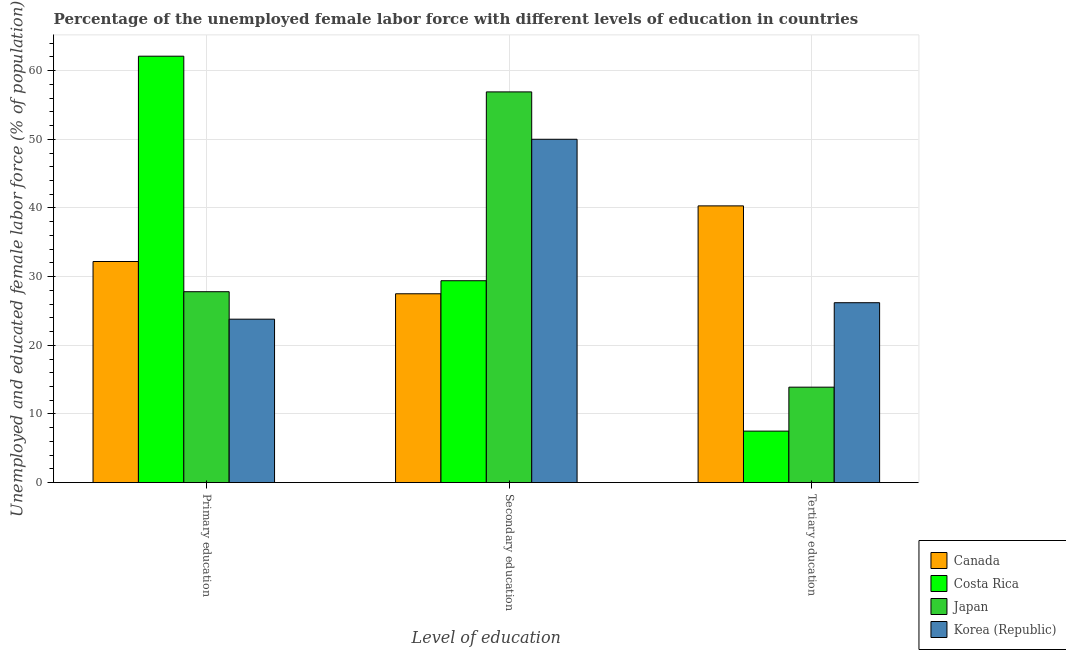How many groups of bars are there?
Keep it short and to the point. 3. How many bars are there on the 2nd tick from the left?
Give a very brief answer. 4. What is the label of the 1st group of bars from the left?
Provide a short and direct response. Primary education. What is the percentage of female labor force who received tertiary education in Canada?
Ensure brevity in your answer.  40.3. Across all countries, what is the maximum percentage of female labor force who received primary education?
Provide a short and direct response. 62.1. In which country was the percentage of female labor force who received tertiary education maximum?
Offer a terse response. Canada. What is the total percentage of female labor force who received secondary education in the graph?
Your response must be concise. 163.8. What is the difference between the percentage of female labor force who received tertiary education in Korea (Republic) and that in Costa Rica?
Give a very brief answer. 18.7. What is the difference between the percentage of female labor force who received tertiary education in Korea (Republic) and the percentage of female labor force who received secondary education in Japan?
Provide a short and direct response. -30.7. What is the average percentage of female labor force who received primary education per country?
Provide a short and direct response. 36.47. What is the difference between the percentage of female labor force who received primary education and percentage of female labor force who received tertiary education in Japan?
Keep it short and to the point. 13.9. In how many countries, is the percentage of female labor force who received tertiary education greater than 58 %?
Provide a succinct answer. 0. What is the ratio of the percentage of female labor force who received primary education in Canada to that in Costa Rica?
Your answer should be compact. 0.52. Is the percentage of female labor force who received primary education in Korea (Republic) less than that in Costa Rica?
Keep it short and to the point. Yes. What is the difference between the highest and the second highest percentage of female labor force who received secondary education?
Your response must be concise. 6.9. What is the difference between the highest and the lowest percentage of female labor force who received tertiary education?
Provide a short and direct response. 32.8. In how many countries, is the percentage of female labor force who received secondary education greater than the average percentage of female labor force who received secondary education taken over all countries?
Give a very brief answer. 2. How many bars are there?
Make the answer very short. 12. How many countries are there in the graph?
Make the answer very short. 4. What is the difference between two consecutive major ticks on the Y-axis?
Provide a short and direct response. 10. Does the graph contain any zero values?
Provide a succinct answer. No. How many legend labels are there?
Keep it short and to the point. 4. What is the title of the graph?
Offer a very short reply. Percentage of the unemployed female labor force with different levels of education in countries. Does "Middle East & North Africa (developing only)" appear as one of the legend labels in the graph?
Offer a terse response. No. What is the label or title of the X-axis?
Ensure brevity in your answer.  Level of education. What is the label or title of the Y-axis?
Your response must be concise. Unemployed and educated female labor force (% of population). What is the Unemployed and educated female labor force (% of population) of Canada in Primary education?
Offer a terse response. 32.2. What is the Unemployed and educated female labor force (% of population) in Costa Rica in Primary education?
Your response must be concise. 62.1. What is the Unemployed and educated female labor force (% of population) of Japan in Primary education?
Provide a short and direct response. 27.8. What is the Unemployed and educated female labor force (% of population) of Korea (Republic) in Primary education?
Provide a succinct answer. 23.8. What is the Unemployed and educated female labor force (% of population) of Costa Rica in Secondary education?
Your answer should be very brief. 29.4. What is the Unemployed and educated female labor force (% of population) of Japan in Secondary education?
Offer a terse response. 56.9. What is the Unemployed and educated female labor force (% of population) in Canada in Tertiary education?
Provide a short and direct response. 40.3. What is the Unemployed and educated female labor force (% of population) of Japan in Tertiary education?
Your answer should be compact. 13.9. What is the Unemployed and educated female labor force (% of population) of Korea (Republic) in Tertiary education?
Your response must be concise. 26.2. Across all Level of education, what is the maximum Unemployed and educated female labor force (% of population) in Canada?
Provide a short and direct response. 40.3. Across all Level of education, what is the maximum Unemployed and educated female labor force (% of population) of Costa Rica?
Offer a very short reply. 62.1. Across all Level of education, what is the maximum Unemployed and educated female labor force (% of population) of Japan?
Your response must be concise. 56.9. Across all Level of education, what is the maximum Unemployed and educated female labor force (% of population) in Korea (Republic)?
Your answer should be compact. 50. Across all Level of education, what is the minimum Unemployed and educated female labor force (% of population) of Canada?
Your answer should be compact. 27.5. Across all Level of education, what is the minimum Unemployed and educated female labor force (% of population) in Costa Rica?
Your answer should be very brief. 7.5. Across all Level of education, what is the minimum Unemployed and educated female labor force (% of population) of Japan?
Your answer should be compact. 13.9. Across all Level of education, what is the minimum Unemployed and educated female labor force (% of population) of Korea (Republic)?
Your answer should be very brief. 23.8. What is the total Unemployed and educated female labor force (% of population) of Canada in the graph?
Ensure brevity in your answer.  100. What is the total Unemployed and educated female labor force (% of population) of Costa Rica in the graph?
Give a very brief answer. 99. What is the total Unemployed and educated female labor force (% of population) in Japan in the graph?
Offer a very short reply. 98.6. What is the total Unemployed and educated female labor force (% of population) in Korea (Republic) in the graph?
Your answer should be compact. 100. What is the difference between the Unemployed and educated female labor force (% of population) in Costa Rica in Primary education and that in Secondary education?
Your answer should be compact. 32.7. What is the difference between the Unemployed and educated female labor force (% of population) of Japan in Primary education and that in Secondary education?
Give a very brief answer. -29.1. What is the difference between the Unemployed and educated female labor force (% of population) in Korea (Republic) in Primary education and that in Secondary education?
Make the answer very short. -26.2. What is the difference between the Unemployed and educated female labor force (% of population) of Costa Rica in Primary education and that in Tertiary education?
Offer a terse response. 54.6. What is the difference between the Unemployed and educated female labor force (% of population) of Japan in Primary education and that in Tertiary education?
Offer a very short reply. 13.9. What is the difference between the Unemployed and educated female labor force (% of population) in Korea (Republic) in Primary education and that in Tertiary education?
Keep it short and to the point. -2.4. What is the difference between the Unemployed and educated female labor force (% of population) of Canada in Secondary education and that in Tertiary education?
Your answer should be very brief. -12.8. What is the difference between the Unemployed and educated female labor force (% of population) of Costa Rica in Secondary education and that in Tertiary education?
Offer a very short reply. 21.9. What is the difference between the Unemployed and educated female labor force (% of population) of Japan in Secondary education and that in Tertiary education?
Keep it short and to the point. 43. What is the difference between the Unemployed and educated female labor force (% of population) of Korea (Republic) in Secondary education and that in Tertiary education?
Make the answer very short. 23.8. What is the difference between the Unemployed and educated female labor force (% of population) in Canada in Primary education and the Unemployed and educated female labor force (% of population) in Costa Rica in Secondary education?
Make the answer very short. 2.8. What is the difference between the Unemployed and educated female labor force (% of population) in Canada in Primary education and the Unemployed and educated female labor force (% of population) in Japan in Secondary education?
Offer a terse response. -24.7. What is the difference between the Unemployed and educated female labor force (% of population) of Canada in Primary education and the Unemployed and educated female labor force (% of population) of Korea (Republic) in Secondary education?
Your response must be concise. -17.8. What is the difference between the Unemployed and educated female labor force (% of population) of Costa Rica in Primary education and the Unemployed and educated female labor force (% of population) of Japan in Secondary education?
Ensure brevity in your answer.  5.2. What is the difference between the Unemployed and educated female labor force (% of population) of Japan in Primary education and the Unemployed and educated female labor force (% of population) of Korea (Republic) in Secondary education?
Your response must be concise. -22.2. What is the difference between the Unemployed and educated female labor force (% of population) in Canada in Primary education and the Unemployed and educated female labor force (% of population) in Costa Rica in Tertiary education?
Ensure brevity in your answer.  24.7. What is the difference between the Unemployed and educated female labor force (% of population) of Canada in Primary education and the Unemployed and educated female labor force (% of population) of Japan in Tertiary education?
Provide a succinct answer. 18.3. What is the difference between the Unemployed and educated female labor force (% of population) of Costa Rica in Primary education and the Unemployed and educated female labor force (% of population) of Japan in Tertiary education?
Make the answer very short. 48.2. What is the difference between the Unemployed and educated female labor force (% of population) of Costa Rica in Primary education and the Unemployed and educated female labor force (% of population) of Korea (Republic) in Tertiary education?
Your response must be concise. 35.9. What is the difference between the Unemployed and educated female labor force (% of population) of Canada in Secondary education and the Unemployed and educated female labor force (% of population) of Costa Rica in Tertiary education?
Provide a succinct answer. 20. What is the difference between the Unemployed and educated female labor force (% of population) in Canada in Secondary education and the Unemployed and educated female labor force (% of population) in Korea (Republic) in Tertiary education?
Keep it short and to the point. 1.3. What is the difference between the Unemployed and educated female labor force (% of population) of Japan in Secondary education and the Unemployed and educated female labor force (% of population) of Korea (Republic) in Tertiary education?
Your answer should be compact. 30.7. What is the average Unemployed and educated female labor force (% of population) of Canada per Level of education?
Ensure brevity in your answer.  33.33. What is the average Unemployed and educated female labor force (% of population) of Japan per Level of education?
Provide a short and direct response. 32.87. What is the average Unemployed and educated female labor force (% of population) in Korea (Republic) per Level of education?
Keep it short and to the point. 33.33. What is the difference between the Unemployed and educated female labor force (% of population) in Canada and Unemployed and educated female labor force (% of population) in Costa Rica in Primary education?
Provide a short and direct response. -29.9. What is the difference between the Unemployed and educated female labor force (% of population) in Canada and Unemployed and educated female labor force (% of population) in Japan in Primary education?
Your answer should be compact. 4.4. What is the difference between the Unemployed and educated female labor force (% of population) in Costa Rica and Unemployed and educated female labor force (% of population) in Japan in Primary education?
Provide a succinct answer. 34.3. What is the difference between the Unemployed and educated female labor force (% of population) of Costa Rica and Unemployed and educated female labor force (% of population) of Korea (Republic) in Primary education?
Offer a very short reply. 38.3. What is the difference between the Unemployed and educated female labor force (% of population) of Japan and Unemployed and educated female labor force (% of population) of Korea (Republic) in Primary education?
Make the answer very short. 4. What is the difference between the Unemployed and educated female labor force (% of population) in Canada and Unemployed and educated female labor force (% of population) in Costa Rica in Secondary education?
Your answer should be compact. -1.9. What is the difference between the Unemployed and educated female labor force (% of population) of Canada and Unemployed and educated female labor force (% of population) of Japan in Secondary education?
Ensure brevity in your answer.  -29.4. What is the difference between the Unemployed and educated female labor force (% of population) of Canada and Unemployed and educated female labor force (% of population) of Korea (Republic) in Secondary education?
Your response must be concise. -22.5. What is the difference between the Unemployed and educated female labor force (% of population) in Costa Rica and Unemployed and educated female labor force (% of population) in Japan in Secondary education?
Provide a short and direct response. -27.5. What is the difference between the Unemployed and educated female labor force (% of population) in Costa Rica and Unemployed and educated female labor force (% of population) in Korea (Republic) in Secondary education?
Offer a terse response. -20.6. What is the difference between the Unemployed and educated female labor force (% of population) of Japan and Unemployed and educated female labor force (% of population) of Korea (Republic) in Secondary education?
Ensure brevity in your answer.  6.9. What is the difference between the Unemployed and educated female labor force (% of population) in Canada and Unemployed and educated female labor force (% of population) in Costa Rica in Tertiary education?
Your response must be concise. 32.8. What is the difference between the Unemployed and educated female labor force (% of population) in Canada and Unemployed and educated female labor force (% of population) in Japan in Tertiary education?
Provide a succinct answer. 26.4. What is the difference between the Unemployed and educated female labor force (% of population) of Canada and Unemployed and educated female labor force (% of population) of Korea (Republic) in Tertiary education?
Keep it short and to the point. 14.1. What is the difference between the Unemployed and educated female labor force (% of population) in Costa Rica and Unemployed and educated female labor force (% of population) in Japan in Tertiary education?
Offer a terse response. -6.4. What is the difference between the Unemployed and educated female labor force (% of population) of Costa Rica and Unemployed and educated female labor force (% of population) of Korea (Republic) in Tertiary education?
Offer a very short reply. -18.7. What is the ratio of the Unemployed and educated female labor force (% of population) in Canada in Primary education to that in Secondary education?
Your answer should be very brief. 1.17. What is the ratio of the Unemployed and educated female labor force (% of population) in Costa Rica in Primary education to that in Secondary education?
Ensure brevity in your answer.  2.11. What is the ratio of the Unemployed and educated female labor force (% of population) in Japan in Primary education to that in Secondary education?
Give a very brief answer. 0.49. What is the ratio of the Unemployed and educated female labor force (% of population) of Korea (Republic) in Primary education to that in Secondary education?
Provide a succinct answer. 0.48. What is the ratio of the Unemployed and educated female labor force (% of population) in Canada in Primary education to that in Tertiary education?
Offer a very short reply. 0.8. What is the ratio of the Unemployed and educated female labor force (% of population) of Costa Rica in Primary education to that in Tertiary education?
Make the answer very short. 8.28. What is the ratio of the Unemployed and educated female labor force (% of population) in Korea (Republic) in Primary education to that in Tertiary education?
Offer a terse response. 0.91. What is the ratio of the Unemployed and educated female labor force (% of population) in Canada in Secondary education to that in Tertiary education?
Offer a terse response. 0.68. What is the ratio of the Unemployed and educated female labor force (% of population) in Costa Rica in Secondary education to that in Tertiary education?
Offer a terse response. 3.92. What is the ratio of the Unemployed and educated female labor force (% of population) of Japan in Secondary education to that in Tertiary education?
Offer a terse response. 4.09. What is the ratio of the Unemployed and educated female labor force (% of population) in Korea (Republic) in Secondary education to that in Tertiary education?
Your answer should be compact. 1.91. What is the difference between the highest and the second highest Unemployed and educated female labor force (% of population) of Canada?
Provide a succinct answer. 8.1. What is the difference between the highest and the second highest Unemployed and educated female labor force (% of population) in Costa Rica?
Provide a succinct answer. 32.7. What is the difference between the highest and the second highest Unemployed and educated female labor force (% of population) in Japan?
Keep it short and to the point. 29.1. What is the difference between the highest and the second highest Unemployed and educated female labor force (% of population) of Korea (Republic)?
Provide a short and direct response. 23.8. What is the difference between the highest and the lowest Unemployed and educated female labor force (% of population) in Canada?
Keep it short and to the point. 12.8. What is the difference between the highest and the lowest Unemployed and educated female labor force (% of population) in Costa Rica?
Give a very brief answer. 54.6. What is the difference between the highest and the lowest Unemployed and educated female labor force (% of population) in Japan?
Your response must be concise. 43. What is the difference between the highest and the lowest Unemployed and educated female labor force (% of population) in Korea (Republic)?
Offer a terse response. 26.2. 